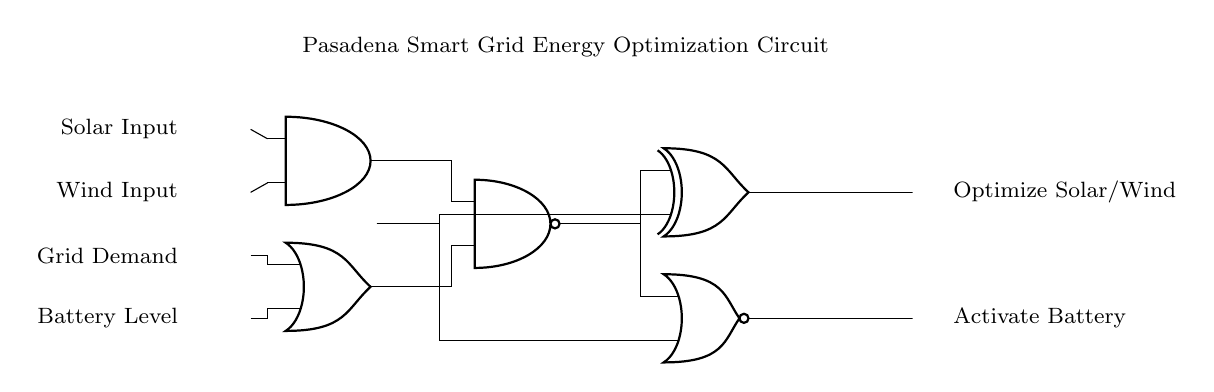What type of input signals are present in the circuit? The input signals are solar input, wind input, grid demand, and battery level, which are explicitly labeled on the left side of the circuit diagram.
Answer: solar input, wind input, grid demand, battery level Which logic gate produces the final output in the circuit? The final outputs are produced by the xor and nor gates, as they are located at the rightmost side of the circuit and directly connected from the nand gate output.
Answer: xor gate, nor gate How many AND gates are used in the circuit? There is one AND gate in the circuit, identifiable by the "and port" symbol labeled at the coordinates given in the circuit.
Answer: one What happens to the solar and wind inputs before reaching the nand gate? The solar and wind inputs are fed into the AND gate, which combines these inputs, and then the AND gate output connects to the nand gate, thus influencing its output.
Answer: AND gate What is the function of the NOR gate in this circuit? The NOR gate acts as a logical operation that outputs true only when both of its inputs are false; in this circuit, it processes the output from the nand gate and battery level to initiate actions based on those inputs.
Answer: outputs true when inputs are false How many different types of logic gates are used in the circuit? There are five different types of logic gates represented in this circuit: AND, OR, NAND, XOR, and NOR. Each type contributes to the overall logical operations needed for energy optimization.
Answer: five What will happen if the battery level input is high while the grid demand is low? If the battery level is high and the grid demand is low, the OR gate will be activated, triggering the NOR gate, which affects the circuit's ability to activate the battery and manage energy efficiently.
Answer: activate battery 